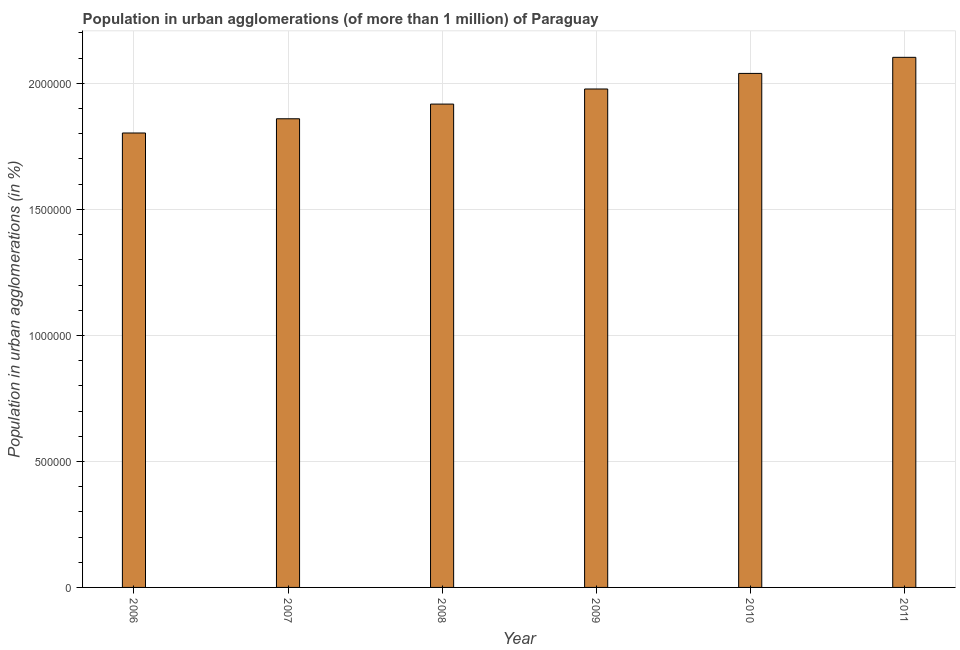What is the title of the graph?
Offer a very short reply. Population in urban agglomerations (of more than 1 million) of Paraguay. What is the label or title of the X-axis?
Offer a terse response. Year. What is the label or title of the Y-axis?
Keep it short and to the point. Population in urban agglomerations (in %). What is the population in urban agglomerations in 2006?
Provide a short and direct response. 1.80e+06. Across all years, what is the maximum population in urban agglomerations?
Make the answer very short. 2.10e+06. Across all years, what is the minimum population in urban agglomerations?
Provide a succinct answer. 1.80e+06. In which year was the population in urban agglomerations maximum?
Provide a succinct answer. 2011. In which year was the population in urban agglomerations minimum?
Offer a very short reply. 2006. What is the sum of the population in urban agglomerations?
Offer a terse response. 1.17e+07. What is the difference between the population in urban agglomerations in 2006 and 2009?
Your answer should be very brief. -1.75e+05. What is the average population in urban agglomerations per year?
Offer a terse response. 1.95e+06. What is the median population in urban agglomerations?
Provide a succinct answer. 1.95e+06. In how many years, is the population in urban agglomerations greater than 1600000 %?
Provide a short and direct response. 6. Is the population in urban agglomerations in 2009 less than that in 2011?
Provide a short and direct response. Yes. Is the difference between the population in urban agglomerations in 2008 and 2009 greater than the difference between any two years?
Make the answer very short. No. What is the difference between the highest and the second highest population in urban agglomerations?
Offer a very short reply. 6.38e+04. Is the sum of the population in urban agglomerations in 2006 and 2008 greater than the maximum population in urban agglomerations across all years?
Make the answer very short. Yes. What is the difference between the highest and the lowest population in urban agglomerations?
Ensure brevity in your answer.  3.00e+05. How many bars are there?
Give a very brief answer. 6. Are all the bars in the graph horizontal?
Your response must be concise. No. What is the Population in urban agglomerations (in %) of 2006?
Your answer should be compact. 1.80e+06. What is the Population in urban agglomerations (in %) in 2007?
Provide a short and direct response. 1.86e+06. What is the Population in urban agglomerations (in %) of 2008?
Your answer should be very brief. 1.92e+06. What is the Population in urban agglomerations (in %) in 2009?
Ensure brevity in your answer.  1.98e+06. What is the Population in urban agglomerations (in %) in 2010?
Give a very brief answer. 2.04e+06. What is the Population in urban agglomerations (in %) in 2011?
Offer a terse response. 2.10e+06. What is the difference between the Population in urban agglomerations (in %) in 2006 and 2007?
Your answer should be very brief. -5.64e+04. What is the difference between the Population in urban agglomerations (in %) in 2006 and 2008?
Offer a terse response. -1.15e+05. What is the difference between the Population in urban agglomerations (in %) in 2006 and 2009?
Offer a very short reply. -1.75e+05. What is the difference between the Population in urban agglomerations (in %) in 2006 and 2010?
Your answer should be compact. -2.36e+05. What is the difference between the Population in urban agglomerations (in %) in 2006 and 2011?
Your response must be concise. -3.00e+05. What is the difference between the Population in urban agglomerations (in %) in 2007 and 2008?
Ensure brevity in your answer.  -5.82e+04. What is the difference between the Population in urban agglomerations (in %) in 2007 and 2009?
Ensure brevity in your answer.  -1.18e+05. What is the difference between the Population in urban agglomerations (in %) in 2007 and 2010?
Offer a very short reply. -1.80e+05. What is the difference between the Population in urban agglomerations (in %) in 2007 and 2011?
Your response must be concise. -2.44e+05. What is the difference between the Population in urban agglomerations (in %) in 2008 and 2009?
Give a very brief answer. -5.99e+04. What is the difference between the Population in urban agglomerations (in %) in 2008 and 2010?
Your response must be concise. -1.22e+05. What is the difference between the Population in urban agglomerations (in %) in 2008 and 2011?
Offer a very short reply. -1.86e+05. What is the difference between the Population in urban agglomerations (in %) in 2009 and 2010?
Your answer should be compact. -6.19e+04. What is the difference between the Population in urban agglomerations (in %) in 2009 and 2011?
Your answer should be compact. -1.26e+05. What is the difference between the Population in urban agglomerations (in %) in 2010 and 2011?
Provide a short and direct response. -6.38e+04. What is the ratio of the Population in urban agglomerations (in %) in 2006 to that in 2007?
Your response must be concise. 0.97. What is the ratio of the Population in urban agglomerations (in %) in 2006 to that in 2009?
Offer a terse response. 0.91. What is the ratio of the Population in urban agglomerations (in %) in 2006 to that in 2010?
Keep it short and to the point. 0.88. What is the ratio of the Population in urban agglomerations (in %) in 2006 to that in 2011?
Your answer should be compact. 0.86. What is the ratio of the Population in urban agglomerations (in %) in 2007 to that in 2008?
Your answer should be very brief. 0.97. What is the ratio of the Population in urban agglomerations (in %) in 2007 to that in 2009?
Give a very brief answer. 0.94. What is the ratio of the Population in urban agglomerations (in %) in 2007 to that in 2010?
Keep it short and to the point. 0.91. What is the ratio of the Population in urban agglomerations (in %) in 2007 to that in 2011?
Offer a very short reply. 0.88. What is the ratio of the Population in urban agglomerations (in %) in 2008 to that in 2010?
Provide a succinct answer. 0.94. What is the ratio of the Population in urban agglomerations (in %) in 2008 to that in 2011?
Keep it short and to the point. 0.91. What is the ratio of the Population in urban agglomerations (in %) in 2010 to that in 2011?
Ensure brevity in your answer.  0.97. 